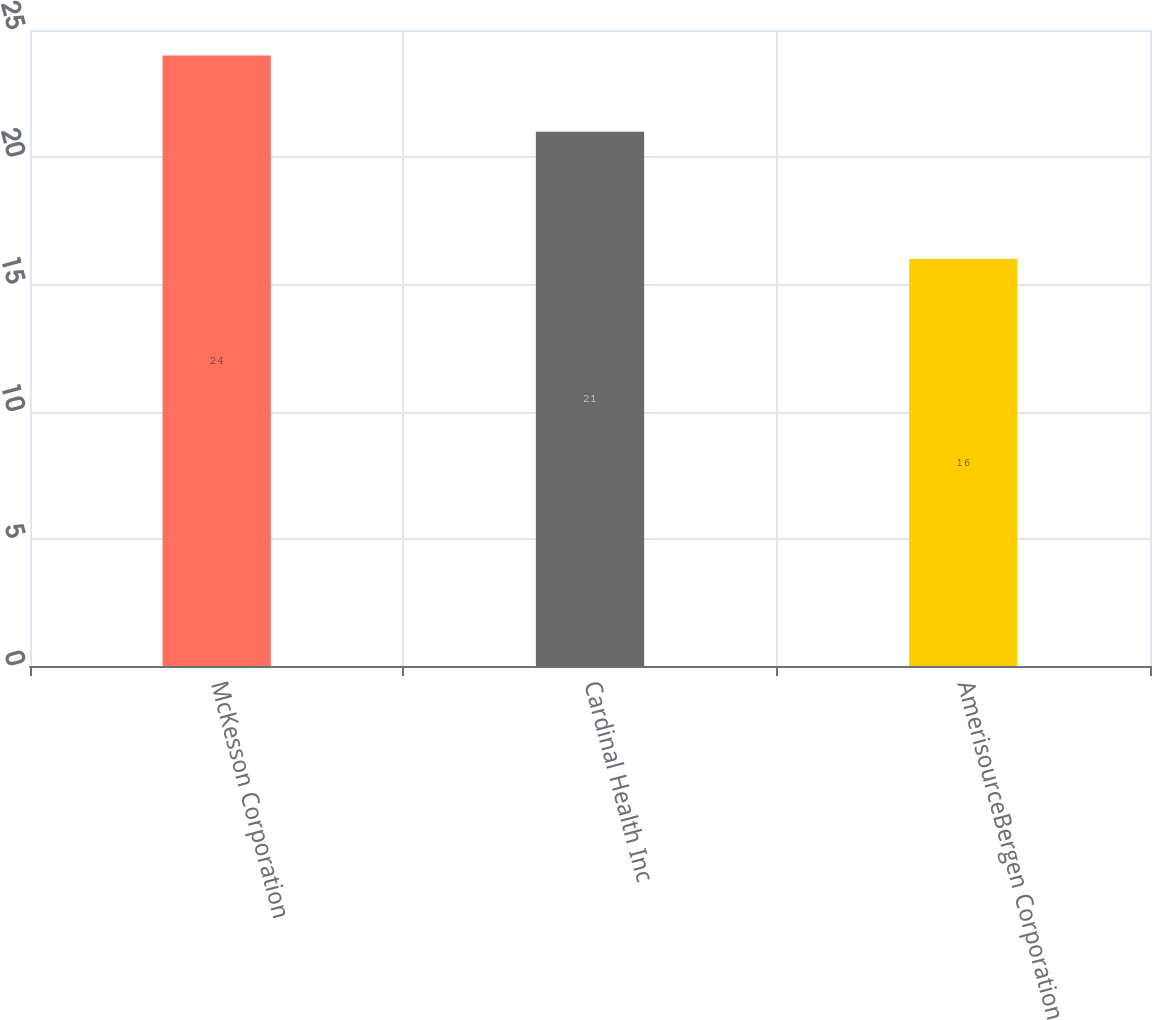<chart> <loc_0><loc_0><loc_500><loc_500><bar_chart><fcel>McKesson Corporation<fcel>Cardinal Health Inc<fcel>AmerisourceBergen Corporation<nl><fcel>24<fcel>21<fcel>16<nl></chart> 